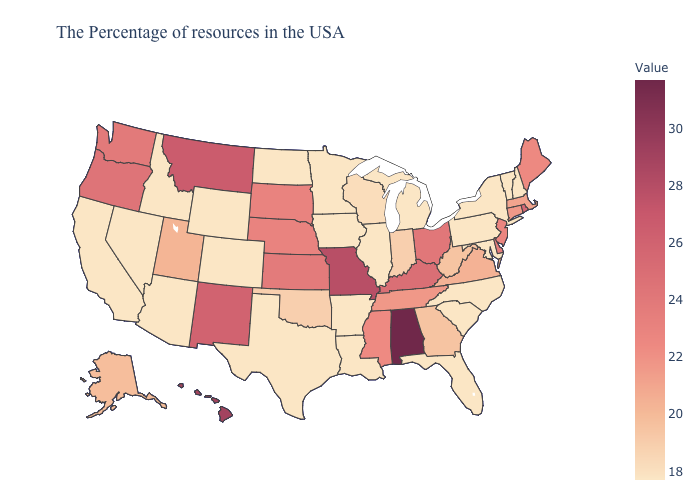Which states have the highest value in the USA?
Answer briefly. Alabama. Does California have the lowest value in the USA?
Answer briefly. Yes. Does Vermont have a higher value than Tennessee?
Short answer required. No. Is the legend a continuous bar?
Quick response, please. Yes. 